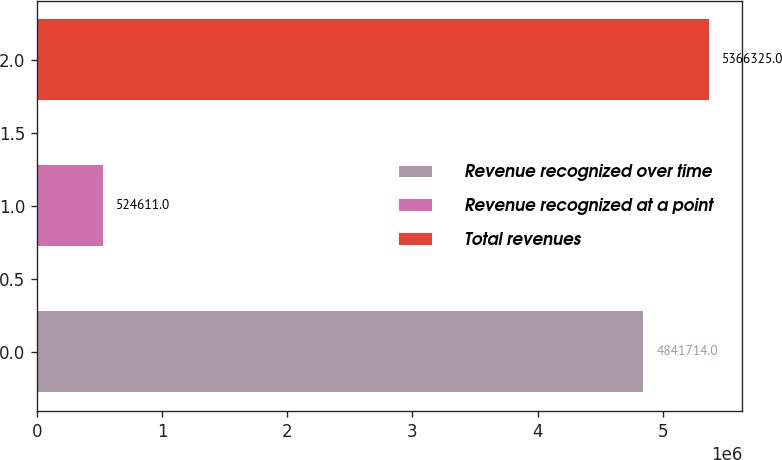<chart> <loc_0><loc_0><loc_500><loc_500><bar_chart><fcel>Revenue recognized over time<fcel>Revenue recognized at a point<fcel>Total revenues<nl><fcel>4.84171e+06<fcel>524611<fcel>5.36632e+06<nl></chart> 